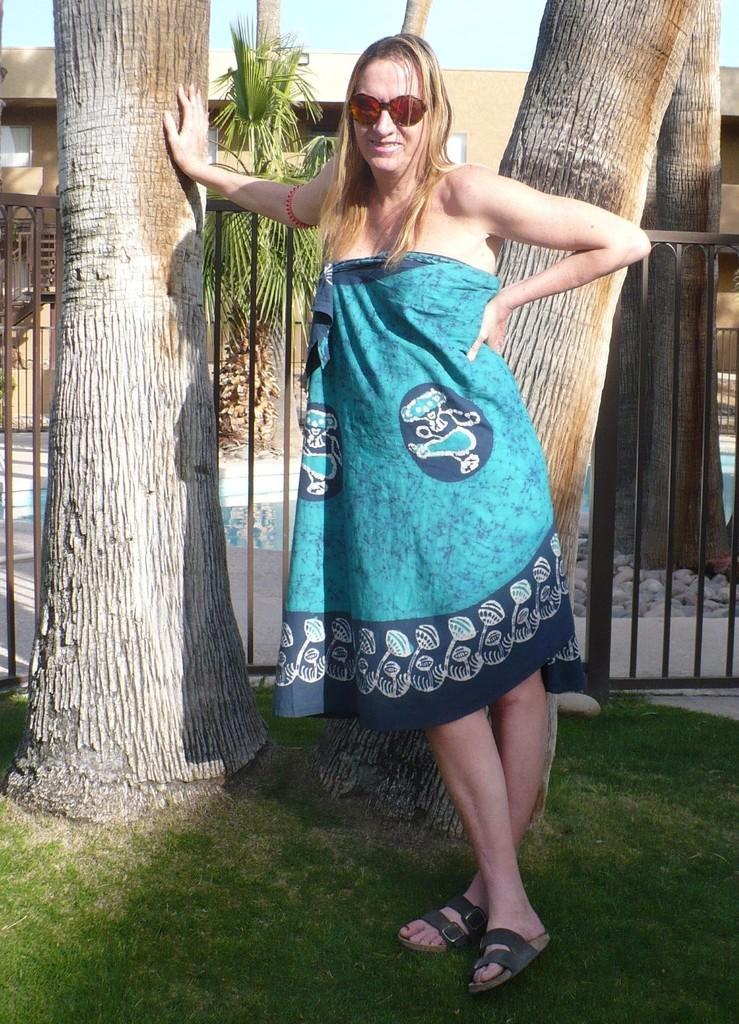Describe this image in one or two sentences. In this picture, there is a woman wearing a blue dress. Behind her, there are trees. At the bottom, there is grass. In the background, there is a building and a sky. 